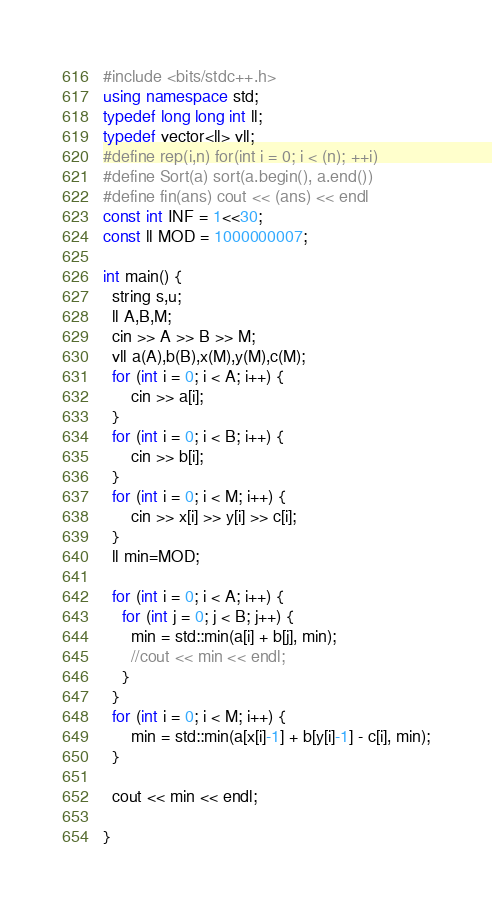Convert code to text. <code><loc_0><loc_0><loc_500><loc_500><_C++_>#include <bits/stdc++.h>
using namespace std;
typedef long long int ll;
typedef vector<ll> vll;
#define rep(i,n) for(int i = 0; i < (n); ++i)
#define Sort(a) sort(a.begin(), a.end())
#define fin(ans) cout << (ans) << endl
const int INF = 1<<30;
const ll MOD = 1000000007;

int main() {
  string s,u;
  ll A,B,M;
  cin >> A >> B >> M;
  vll a(A),b(B),x(M),y(M),c(M);
  for (int i = 0; i < A; i++) {
      cin >> a[i];
  } 
  for (int i = 0; i < B; i++) {
      cin >> b[i];
  }
  for (int i = 0; i < M; i++) {
      cin >> x[i] >> y[i] >> c[i];
  }
  ll min=MOD;

  for (int i = 0; i < A; i++) {
    for (int j = 0; j < B; j++) {
      min = std::min(a[i] + b[j], min);
      //cout << min << endl;
    }
  }
  for (int i = 0; i < M; i++) {
      min = std::min(a[x[i]-1] + b[y[i]-1] - c[i], min);
  }

  cout << min << endl; 
  
}</code> 